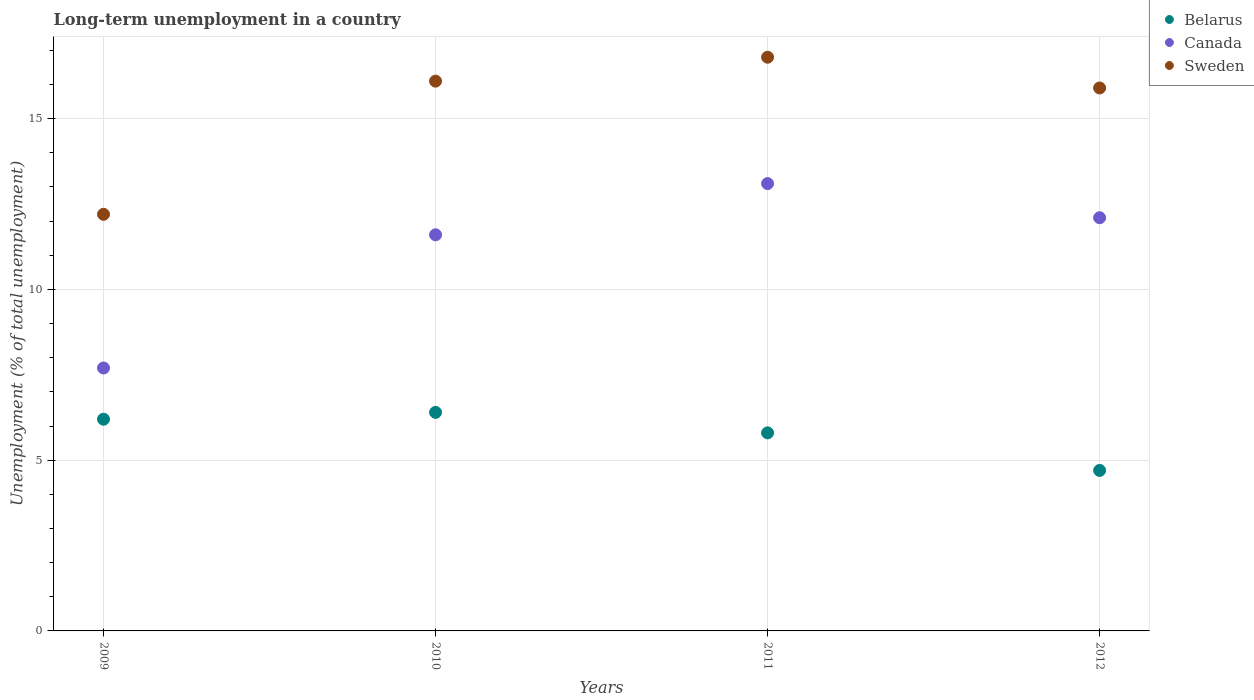How many different coloured dotlines are there?
Keep it short and to the point. 3. What is the percentage of long-term unemployed population in Sweden in 2012?
Your answer should be very brief. 15.9. Across all years, what is the maximum percentage of long-term unemployed population in Canada?
Make the answer very short. 13.1. Across all years, what is the minimum percentage of long-term unemployed population in Sweden?
Provide a succinct answer. 12.2. In which year was the percentage of long-term unemployed population in Canada minimum?
Your answer should be very brief. 2009. What is the total percentage of long-term unemployed population in Belarus in the graph?
Give a very brief answer. 23.1. What is the difference between the percentage of long-term unemployed population in Canada in 2009 and that in 2011?
Offer a very short reply. -5.4. What is the difference between the percentage of long-term unemployed population in Belarus in 2011 and the percentage of long-term unemployed population in Canada in 2010?
Give a very brief answer. -5.8. What is the average percentage of long-term unemployed population in Belarus per year?
Your answer should be compact. 5.77. In the year 2012, what is the difference between the percentage of long-term unemployed population in Canada and percentage of long-term unemployed population in Sweden?
Offer a terse response. -3.8. In how many years, is the percentage of long-term unemployed population in Belarus greater than 8 %?
Offer a terse response. 0. What is the ratio of the percentage of long-term unemployed population in Canada in 2009 to that in 2012?
Offer a very short reply. 0.64. Is the difference between the percentage of long-term unemployed population in Canada in 2011 and 2012 greater than the difference between the percentage of long-term unemployed population in Sweden in 2011 and 2012?
Offer a very short reply. Yes. What is the difference between the highest and the second highest percentage of long-term unemployed population in Sweden?
Your response must be concise. 0.7. What is the difference between the highest and the lowest percentage of long-term unemployed population in Canada?
Give a very brief answer. 5.4. Is the percentage of long-term unemployed population in Canada strictly greater than the percentage of long-term unemployed population in Sweden over the years?
Make the answer very short. No. How many years are there in the graph?
Your response must be concise. 4. Are the values on the major ticks of Y-axis written in scientific E-notation?
Your answer should be very brief. No. Does the graph contain grids?
Your answer should be compact. Yes. Where does the legend appear in the graph?
Make the answer very short. Top right. How many legend labels are there?
Provide a short and direct response. 3. What is the title of the graph?
Keep it short and to the point. Long-term unemployment in a country. What is the label or title of the Y-axis?
Your answer should be compact. Unemployment (% of total unemployment). What is the Unemployment (% of total unemployment) in Belarus in 2009?
Give a very brief answer. 6.2. What is the Unemployment (% of total unemployment) of Canada in 2009?
Your response must be concise. 7.7. What is the Unemployment (% of total unemployment) of Sweden in 2009?
Provide a succinct answer. 12.2. What is the Unemployment (% of total unemployment) of Belarus in 2010?
Make the answer very short. 6.4. What is the Unemployment (% of total unemployment) of Canada in 2010?
Offer a terse response. 11.6. What is the Unemployment (% of total unemployment) in Sweden in 2010?
Your response must be concise. 16.1. What is the Unemployment (% of total unemployment) of Belarus in 2011?
Make the answer very short. 5.8. What is the Unemployment (% of total unemployment) in Canada in 2011?
Offer a very short reply. 13.1. What is the Unemployment (% of total unemployment) of Sweden in 2011?
Provide a short and direct response. 16.8. What is the Unemployment (% of total unemployment) of Belarus in 2012?
Make the answer very short. 4.7. What is the Unemployment (% of total unemployment) in Canada in 2012?
Make the answer very short. 12.1. What is the Unemployment (% of total unemployment) of Sweden in 2012?
Your response must be concise. 15.9. Across all years, what is the maximum Unemployment (% of total unemployment) in Belarus?
Give a very brief answer. 6.4. Across all years, what is the maximum Unemployment (% of total unemployment) in Canada?
Offer a very short reply. 13.1. Across all years, what is the maximum Unemployment (% of total unemployment) of Sweden?
Give a very brief answer. 16.8. Across all years, what is the minimum Unemployment (% of total unemployment) in Belarus?
Your answer should be compact. 4.7. Across all years, what is the minimum Unemployment (% of total unemployment) in Canada?
Make the answer very short. 7.7. Across all years, what is the minimum Unemployment (% of total unemployment) in Sweden?
Your answer should be very brief. 12.2. What is the total Unemployment (% of total unemployment) in Belarus in the graph?
Your response must be concise. 23.1. What is the total Unemployment (% of total unemployment) of Canada in the graph?
Keep it short and to the point. 44.5. What is the difference between the Unemployment (% of total unemployment) in Sweden in 2009 and that in 2010?
Give a very brief answer. -3.9. What is the difference between the Unemployment (% of total unemployment) of Belarus in 2009 and that in 2011?
Provide a succinct answer. 0.4. What is the difference between the Unemployment (% of total unemployment) in Canada in 2009 and that in 2011?
Ensure brevity in your answer.  -5.4. What is the difference between the Unemployment (% of total unemployment) in Sweden in 2009 and that in 2011?
Your response must be concise. -4.6. What is the difference between the Unemployment (% of total unemployment) in Belarus in 2009 and that in 2012?
Your answer should be very brief. 1.5. What is the difference between the Unemployment (% of total unemployment) of Sweden in 2010 and that in 2011?
Provide a short and direct response. -0.7. What is the difference between the Unemployment (% of total unemployment) of Canada in 2010 and that in 2012?
Provide a succinct answer. -0.5. What is the difference between the Unemployment (% of total unemployment) in Sweden in 2010 and that in 2012?
Offer a very short reply. 0.2. What is the difference between the Unemployment (% of total unemployment) in Canada in 2011 and that in 2012?
Provide a short and direct response. 1. What is the difference between the Unemployment (% of total unemployment) in Belarus in 2009 and the Unemployment (% of total unemployment) in Sweden in 2010?
Provide a short and direct response. -9.9. What is the difference between the Unemployment (% of total unemployment) in Belarus in 2009 and the Unemployment (% of total unemployment) in Canada in 2012?
Provide a succinct answer. -5.9. What is the difference between the Unemployment (% of total unemployment) in Canada in 2009 and the Unemployment (% of total unemployment) in Sweden in 2012?
Offer a terse response. -8.2. What is the difference between the Unemployment (% of total unemployment) in Belarus in 2010 and the Unemployment (% of total unemployment) in Sweden in 2011?
Make the answer very short. -10.4. What is the difference between the Unemployment (% of total unemployment) of Belarus in 2010 and the Unemployment (% of total unemployment) of Sweden in 2012?
Your answer should be very brief. -9.5. What is the difference between the Unemployment (% of total unemployment) of Belarus in 2011 and the Unemployment (% of total unemployment) of Canada in 2012?
Provide a succinct answer. -6.3. What is the difference between the Unemployment (% of total unemployment) in Canada in 2011 and the Unemployment (% of total unemployment) in Sweden in 2012?
Your answer should be compact. -2.8. What is the average Unemployment (% of total unemployment) of Belarus per year?
Keep it short and to the point. 5.78. What is the average Unemployment (% of total unemployment) of Canada per year?
Provide a succinct answer. 11.12. What is the average Unemployment (% of total unemployment) in Sweden per year?
Your response must be concise. 15.25. In the year 2009, what is the difference between the Unemployment (% of total unemployment) of Belarus and Unemployment (% of total unemployment) of Canada?
Your answer should be very brief. -1.5. In the year 2009, what is the difference between the Unemployment (% of total unemployment) of Belarus and Unemployment (% of total unemployment) of Sweden?
Offer a very short reply. -6. In the year 2010, what is the difference between the Unemployment (% of total unemployment) of Belarus and Unemployment (% of total unemployment) of Canada?
Give a very brief answer. -5.2. In the year 2010, what is the difference between the Unemployment (% of total unemployment) of Belarus and Unemployment (% of total unemployment) of Sweden?
Your response must be concise. -9.7. In the year 2010, what is the difference between the Unemployment (% of total unemployment) in Canada and Unemployment (% of total unemployment) in Sweden?
Give a very brief answer. -4.5. In the year 2011, what is the difference between the Unemployment (% of total unemployment) of Belarus and Unemployment (% of total unemployment) of Sweden?
Offer a terse response. -11. In the year 2012, what is the difference between the Unemployment (% of total unemployment) of Belarus and Unemployment (% of total unemployment) of Canada?
Offer a terse response. -7.4. In the year 2012, what is the difference between the Unemployment (% of total unemployment) in Canada and Unemployment (% of total unemployment) in Sweden?
Offer a terse response. -3.8. What is the ratio of the Unemployment (% of total unemployment) in Belarus in 2009 to that in 2010?
Keep it short and to the point. 0.97. What is the ratio of the Unemployment (% of total unemployment) in Canada in 2009 to that in 2010?
Provide a short and direct response. 0.66. What is the ratio of the Unemployment (% of total unemployment) in Sweden in 2009 to that in 2010?
Offer a very short reply. 0.76. What is the ratio of the Unemployment (% of total unemployment) in Belarus in 2009 to that in 2011?
Make the answer very short. 1.07. What is the ratio of the Unemployment (% of total unemployment) of Canada in 2009 to that in 2011?
Give a very brief answer. 0.59. What is the ratio of the Unemployment (% of total unemployment) of Sweden in 2009 to that in 2011?
Offer a very short reply. 0.73. What is the ratio of the Unemployment (% of total unemployment) in Belarus in 2009 to that in 2012?
Offer a terse response. 1.32. What is the ratio of the Unemployment (% of total unemployment) of Canada in 2009 to that in 2012?
Your answer should be very brief. 0.64. What is the ratio of the Unemployment (% of total unemployment) of Sweden in 2009 to that in 2012?
Offer a very short reply. 0.77. What is the ratio of the Unemployment (% of total unemployment) of Belarus in 2010 to that in 2011?
Keep it short and to the point. 1.1. What is the ratio of the Unemployment (% of total unemployment) in Canada in 2010 to that in 2011?
Make the answer very short. 0.89. What is the ratio of the Unemployment (% of total unemployment) of Sweden in 2010 to that in 2011?
Your response must be concise. 0.96. What is the ratio of the Unemployment (% of total unemployment) of Belarus in 2010 to that in 2012?
Your response must be concise. 1.36. What is the ratio of the Unemployment (% of total unemployment) in Canada in 2010 to that in 2012?
Ensure brevity in your answer.  0.96. What is the ratio of the Unemployment (% of total unemployment) in Sweden in 2010 to that in 2012?
Offer a terse response. 1.01. What is the ratio of the Unemployment (% of total unemployment) in Belarus in 2011 to that in 2012?
Give a very brief answer. 1.23. What is the ratio of the Unemployment (% of total unemployment) in Canada in 2011 to that in 2012?
Make the answer very short. 1.08. What is the ratio of the Unemployment (% of total unemployment) of Sweden in 2011 to that in 2012?
Provide a succinct answer. 1.06. What is the difference between the highest and the second highest Unemployment (% of total unemployment) of Canada?
Keep it short and to the point. 1. What is the difference between the highest and the second highest Unemployment (% of total unemployment) in Sweden?
Make the answer very short. 0.7. What is the difference between the highest and the lowest Unemployment (% of total unemployment) in Canada?
Your response must be concise. 5.4. 